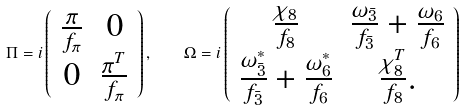Convert formula to latex. <formula><loc_0><loc_0><loc_500><loc_500>\Pi = i \left ( \begin{array} { c c } { { \frac { \pi } { f _ { \pi } } } } & { 0 } \\ { 0 } & { { \frac { \pi ^ { T } } { f _ { \pi } } } } \end{array} \right ) , \quad \Omega = i \left ( \begin{array} { c c } { { \frac { \chi _ { 8 } } { f _ { 8 } } } } & { { \frac { \omega _ { \bar { 3 } } } { f _ { \bar { 3 } } } + \frac { \omega _ { 6 } } { f _ { 6 } } } } \\ { { \frac { \omega _ { \bar { 3 } } ^ { * } } { f _ { \bar { 3 } } } + \frac { \omega _ { 6 } ^ { * } } { f _ { 6 } } } } & { { \frac { \chi _ { 8 } ^ { T } } { f _ { 8 } } . } } \end{array} \right )</formula> 